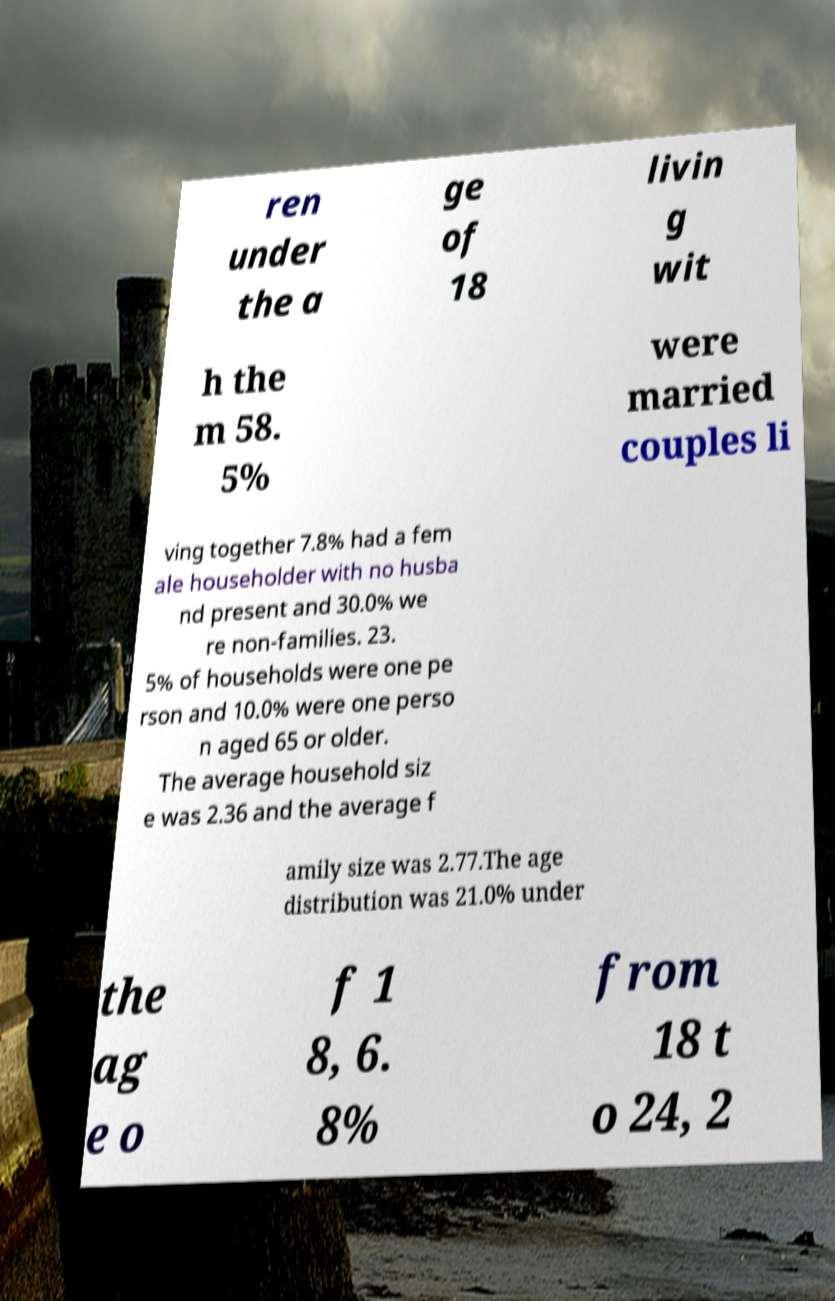Can you accurately transcribe the text from the provided image for me? ren under the a ge of 18 livin g wit h the m 58. 5% were married couples li ving together 7.8% had a fem ale householder with no husba nd present and 30.0% we re non-families. 23. 5% of households were one pe rson and 10.0% were one perso n aged 65 or older. The average household siz e was 2.36 and the average f amily size was 2.77.The age distribution was 21.0% under the ag e o f 1 8, 6. 8% from 18 t o 24, 2 